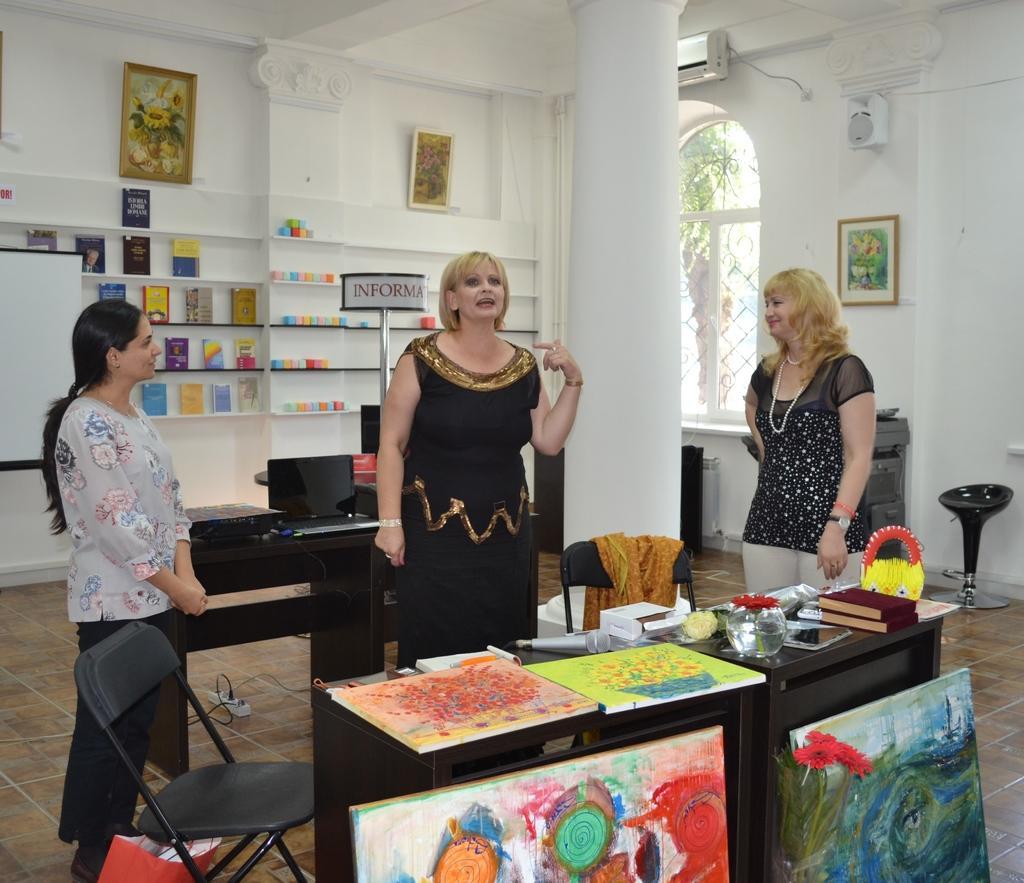Describe this image in one or two sentences. In this picture there is a woman who is wearing black dress. She is standing near to the table. On the table we can see books, papers, posters, flowers and water. On the bottom we can see painting frames. On the right there is another woman who is wearing black dress, locket and watch. She is smiling. On the left we can see another woman who is standing near to the chair. In the back we can see papers, candles and other objects on the rack. Here we can see window near to the AC. Through the window we can see tree. 